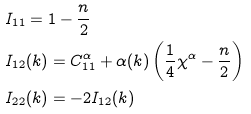<formula> <loc_0><loc_0><loc_500><loc_500>& I _ { 1 1 } = 1 - \frac { n } { 2 } \\ & I _ { 1 2 } ( k ) = C _ { 1 1 } ^ { \alpha } + \alpha ( k ) \left ( \frac { 1 } { 4 } \chi ^ { \alpha } - \frac { n } { 2 } \right ) \\ & I _ { 2 2 } ( k ) = - 2 I _ { 1 2 } ( k )</formula> 